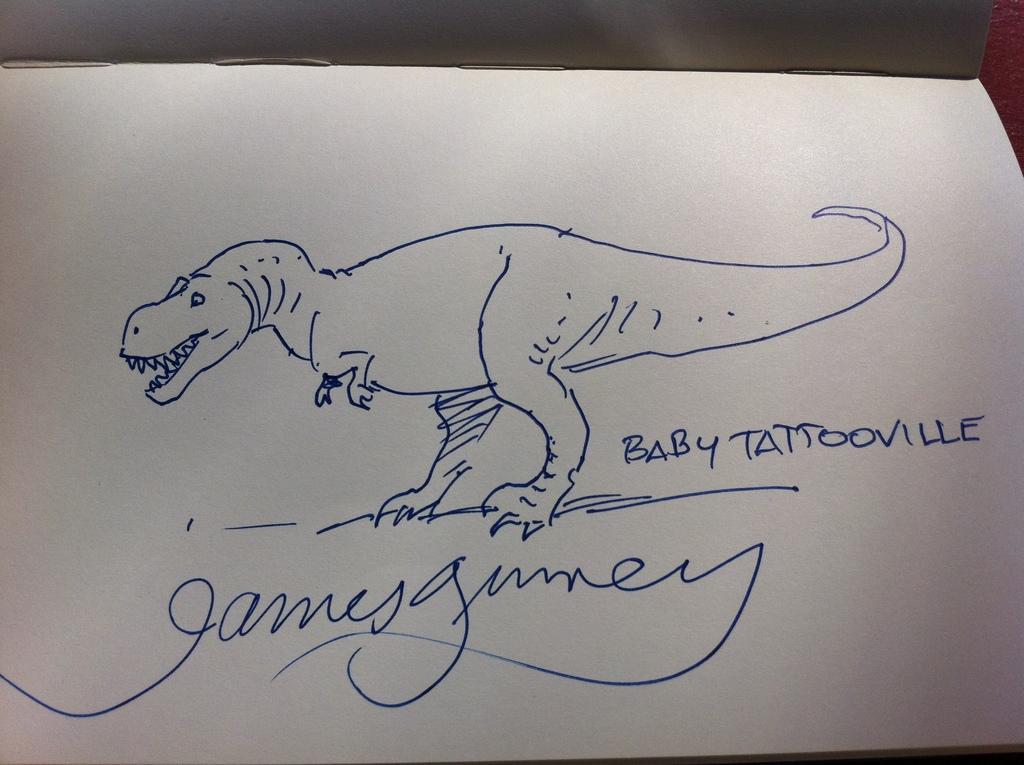Please provide a concise description of this image. In this image I can see a drawing of a dinosaur and some text on a white paper. It seems to be a book. 